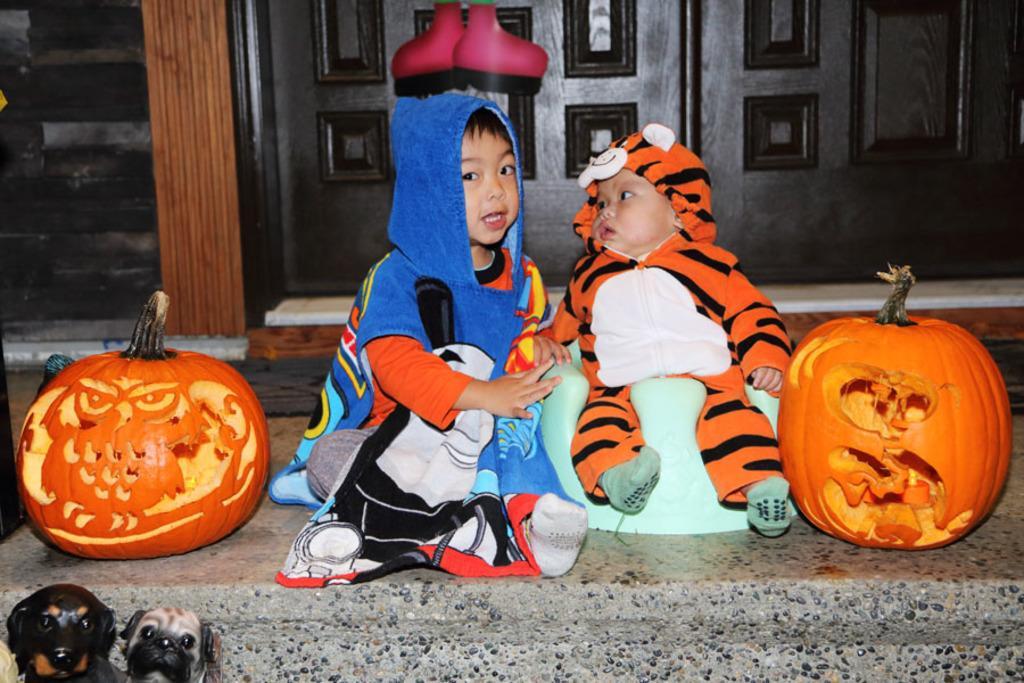Describe this image in one or two sentences. The boy in red T-shirt and blue jacket is sitting and he is trying to talk something. Beside him, the baby in orange jacket is sitting on the bean bag. On either side of the picture, there are two carved pumpkins. Behind them, we see a door in black color. In the left bottom of the picture, there are two puppies. 